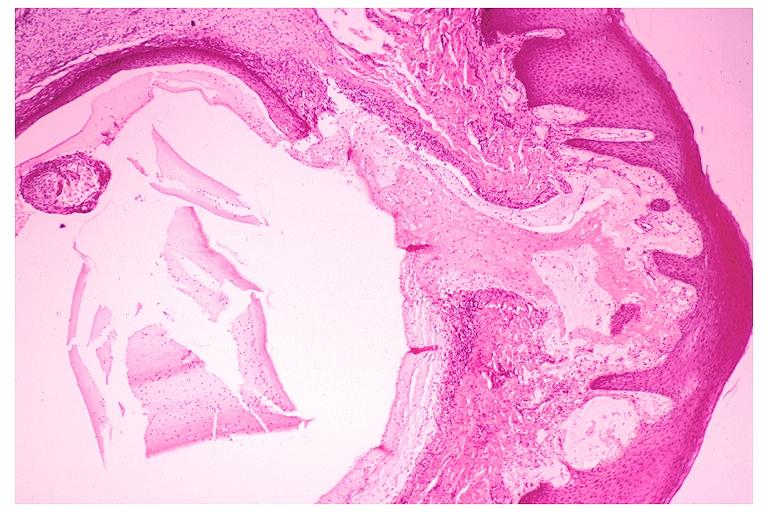s oral present?
Answer the question using a single word or phrase. Yes 